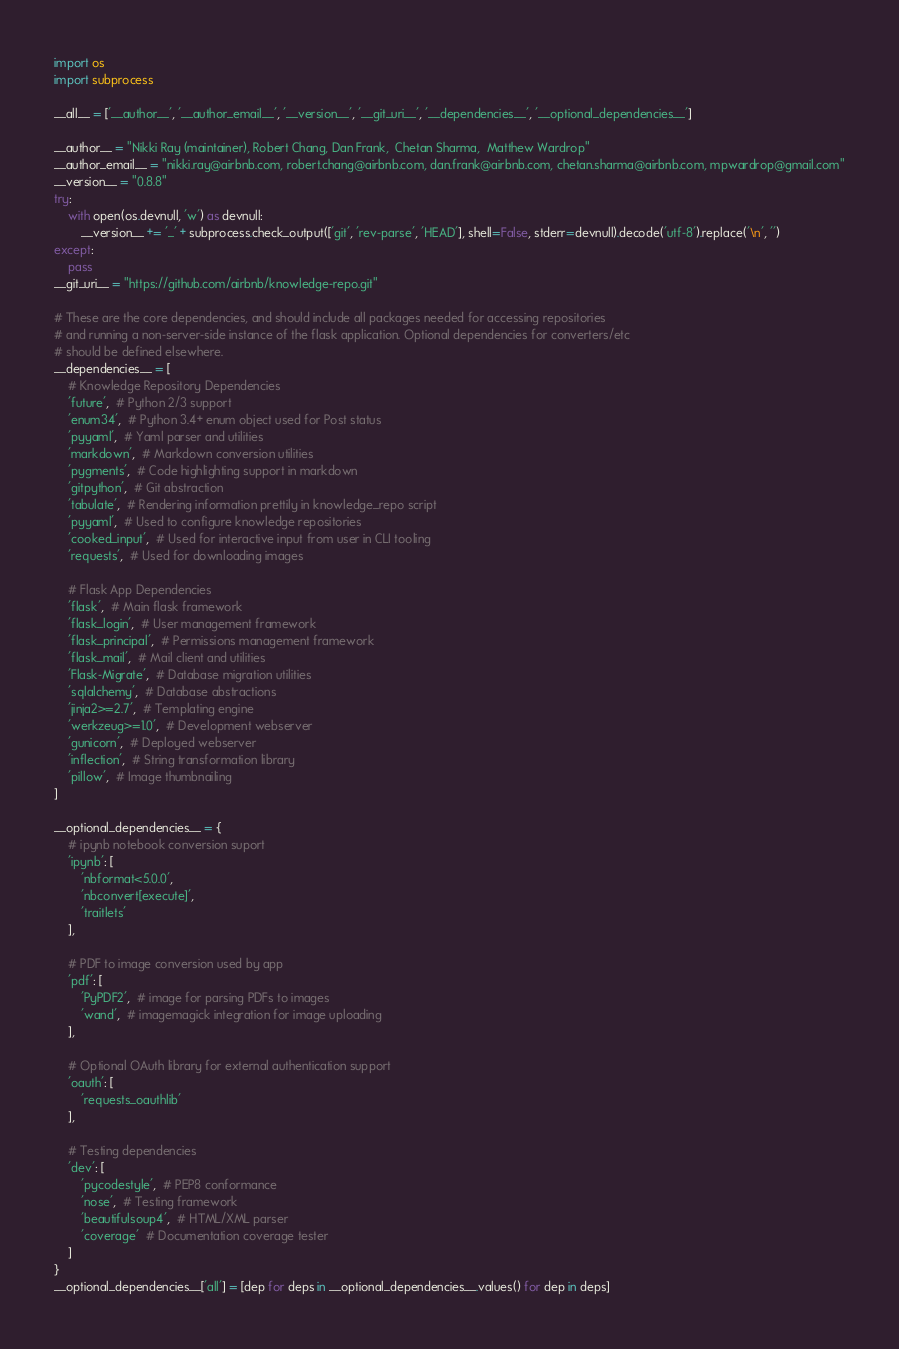<code> <loc_0><loc_0><loc_500><loc_500><_Python_>import os
import subprocess

__all__ = ['__author__', '__author_email__', '__version__', '__git_uri__', '__dependencies__', '__optional_dependencies__']

__author__ = "Nikki Ray (maintainer), Robert Chang, Dan Frank,  Chetan Sharma,  Matthew Wardrop"
__author_email__ = "nikki.ray@airbnb.com, robert.chang@airbnb.com, dan.frank@airbnb.com, chetan.sharma@airbnb.com, mpwardrop@gmail.com"
__version__ = "0.8.8"
try:
    with open(os.devnull, 'w') as devnull:
        __version__ += '_' + subprocess.check_output(['git', 'rev-parse', 'HEAD'], shell=False, stderr=devnull).decode('utf-8').replace('\n', '')
except:
    pass
__git_uri__ = "https://github.com/airbnb/knowledge-repo.git"

# These are the core dependencies, and should include all packages needed for accessing repositories
# and running a non-server-side instance of the flask application. Optional dependencies for converters/etc
# should be defined elsewhere.
__dependencies__ = [
    # Knowledge Repository Dependencies
    'future',  # Python 2/3 support
    'enum34',  # Python 3.4+ enum object used for Post status
    'pyyaml',  # Yaml parser and utilities
    'markdown',  # Markdown conversion utilities
    'pygments',  # Code highlighting support in markdown
    'gitpython',  # Git abstraction
    'tabulate',  # Rendering information prettily in knowledge_repo script
    'pyyaml',  # Used to configure knowledge repositories
    'cooked_input',  # Used for interactive input from user in CLI tooling
    'requests',  # Used for downloading images

    # Flask App Dependencies
    'flask',  # Main flask framework
    'flask_login',  # User management framework
    'flask_principal',  # Permissions management framework
    'flask_mail',  # Mail client and utilities
    'Flask-Migrate',  # Database migration utilities
    'sqlalchemy',  # Database abstractions
    'jinja2>=2.7',  # Templating engine
    'werkzeug>=1.0',  # Development webserver
    'gunicorn',  # Deployed webserver
    'inflection',  # String transformation library
    'pillow',  # Image thumbnailing
]

__optional_dependencies__ = {
    # ipynb notebook conversion suport
    'ipynb': [
        'nbformat<5.0.0',
        'nbconvert[execute]',
        'traitlets'
    ],

    # PDF to image conversion used by app
    'pdf': [
        'PyPDF2',  # image for parsing PDFs to images
        'wand',  # imagemagick integration for image uploading
    ],

    # Optional OAuth library for external authentication support
    'oauth': [
        'requests_oauthlib'
    ],

    # Testing dependencies
    'dev': [
        'pycodestyle',  # PEP8 conformance
        'nose',  # Testing framework
        'beautifulsoup4',  # HTML/XML parser
        'coverage'  # Documentation coverage tester
    ]
}
__optional_dependencies__['all'] = [dep for deps in __optional_dependencies__.values() for dep in deps]
</code> 